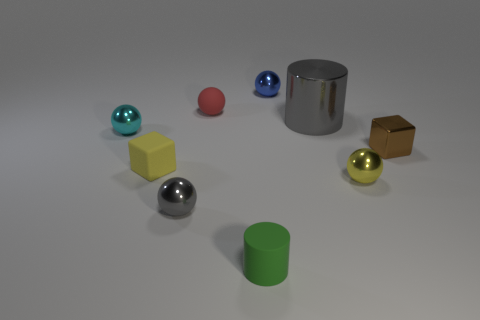Subtract all red spheres. How many spheres are left? 4 Subtract all yellow balls. How many balls are left? 4 Subtract all brown balls. Subtract all purple cylinders. How many balls are left? 5 Subtract all cylinders. How many objects are left? 7 Add 4 tiny cyan spheres. How many tiny cyan spheres are left? 5 Add 6 big metallic things. How many big metallic things exist? 7 Subtract 0 red cylinders. How many objects are left? 9 Subtract all cyan spheres. Subtract all tiny green rubber cylinders. How many objects are left? 7 